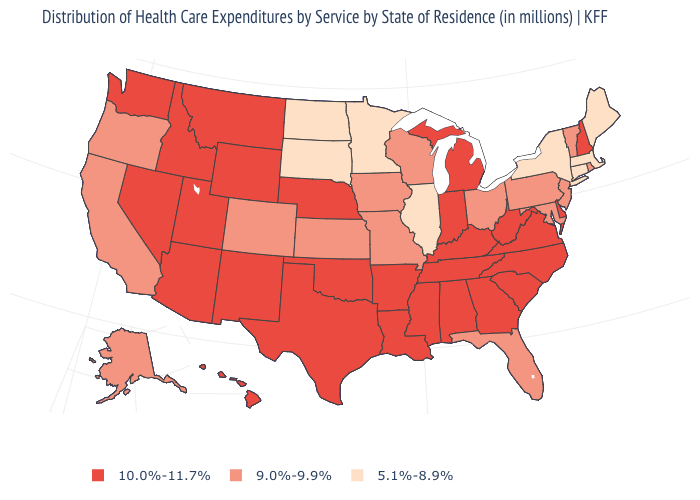Which states have the highest value in the USA?
Keep it brief. Alabama, Arizona, Arkansas, Delaware, Georgia, Hawaii, Idaho, Indiana, Kentucky, Louisiana, Michigan, Mississippi, Montana, Nebraska, Nevada, New Hampshire, New Mexico, North Carolina, Oklahoma, South Carolina, Tennessee, Texas, Utah, Virginia, Washington, West Virginia, Wyoming. Does Maryland have a lower value than South Carolina?
Concise answer only. Yes. Name the states that have a value in the range 5.1%-8.9%?
Be succinct. Connecticut, Illinois, Maine, Massachusetts, Minnesota, New York, North Dakota, South Dakota. Name the states that have a value in the range 5.1%-8.9%?
Answer briefly. Connecticut, Illinois, Maine, Massachusetts, Minnesota, New York, North Dakota, South Dakota. Does the first symbol in the legend represent the smallest category?
Give a very brief answer. No. Does Minnesota have the lowest value in the MidWest?
Give a very brief answer. Yes. What is the lowest value in states that border Vermont?
Be succinct. 5.1%-8.9%. Name the states that have a value in the range 10.0%-11.7%?
Keep it brief. Alabama, Arizona, Arkansas, Delaware, Georgia, Hawaii, Idaho, Indiana, Kentucky, Louisiana, Michigan, Mississippi, Montana, Nebraska, Nevada, New Hampshire, New Mexico, North Carolina, Oklahoma, South Carolina, Tennessee, Texas, Utah, Virginia, Washington, West Virginia, Wyoming. Name the states that have a value in the range 10.0%-11.7%?
Quick response, please. Alabama, Arizona, Arkansas, Delaware, Georgia, Hawaii, Idaho, Indiana, Kentucky, Louisiana, Michigan, Mississippi, Montana, Nebraska, Nevada, New Hampshire, New Mexico, North Carolina, Oklahoma, South Carolina, Tennessee, Texas, Utah, Virginia, Washington, West Virginia, Wyoming. What is the value of Wyoming?
Quick response, please. 10.0%-11.7%. Which states have the lowest value in the MidWest?
Give a very brief answer. Illinois, Minnesota, North Dakota, South Dakota. Does Pennsylvania have the lowest value in the Northeast?
Be succinct. No. What is the lowest value in states that border Oregon?
Write a very short answer. 9.0%-9.9%. Does the map have missing data?
Give a very brief answer. No. Name the states that have a value in the range 10.0%-11.7%?
Be succinct. Alabama, Arizona, Arkansas, Delaware, Georgia, Hawaii, Idaho, Indiana, Kentucky, Louisiana, Michigan, Mississippi, Montana, Nebraska, Nevada, New Hampshire, New Mexico, North Carolina, Oklahoma, South Carolina, Tennessee, Texas, Utah, Virginia, Washington, West Virginia, Wyoming. 